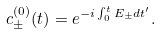<formula> <loc_0><loc_0><loc_500><loc_500>c _ { \pm } ^ { ( 0 ) } ( t ) = e ^ { - i \int _ { 0 } ^ { t } E _ { \pm } d t ^ { \prime } } .</formula> 